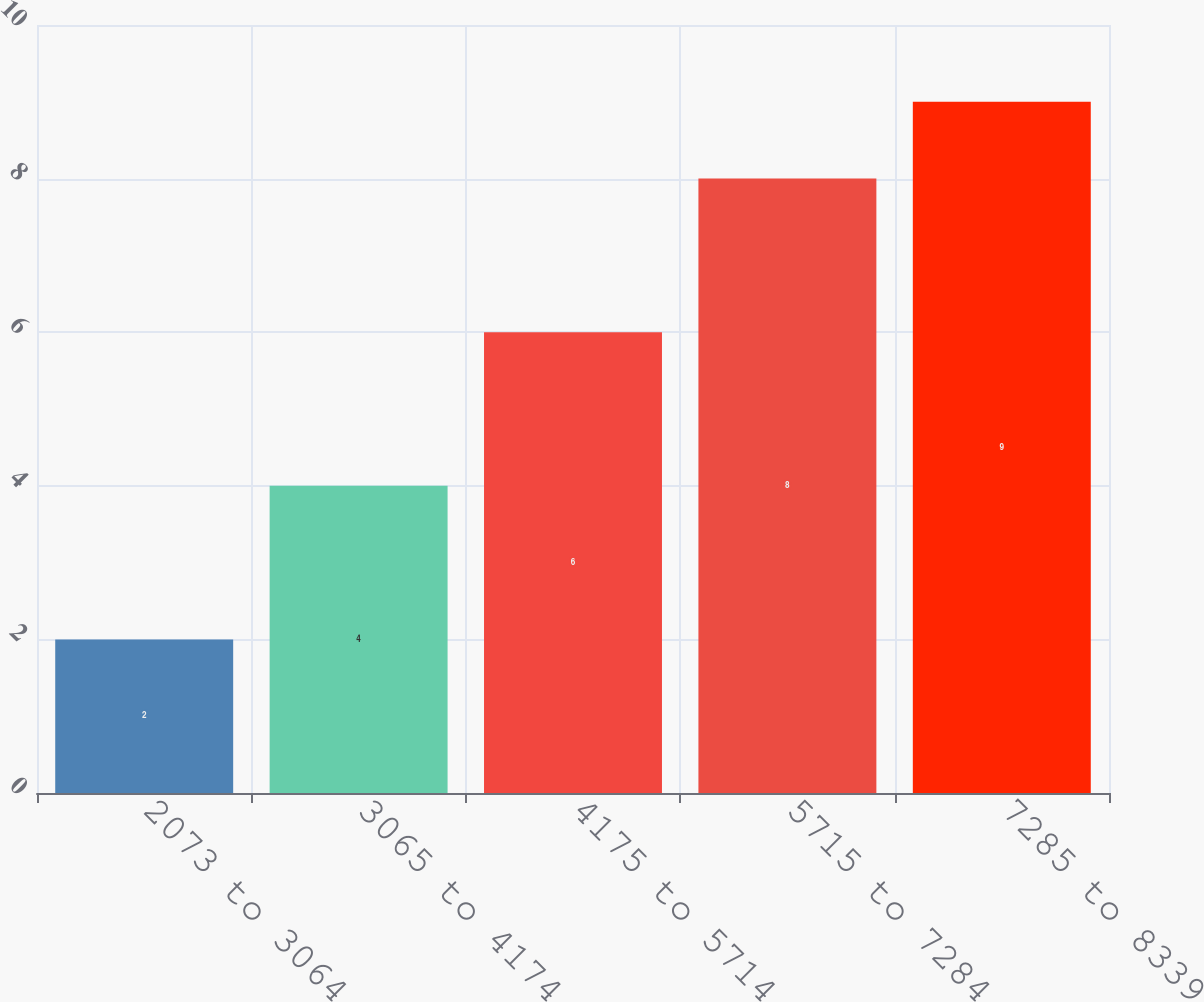Convert chart. <chart><loc_0><loc_0><loc_500><loc_500><bar_chart><fcel>2073 to 3064<fcel>3065 to 4174<fcel>4175 to 5714<fcel>5715 to 7284<fcel>7285 to 8339<nl><fcel>2<fcel>4<fcel>6<fcel>8<fcel>9<nl></chart> 